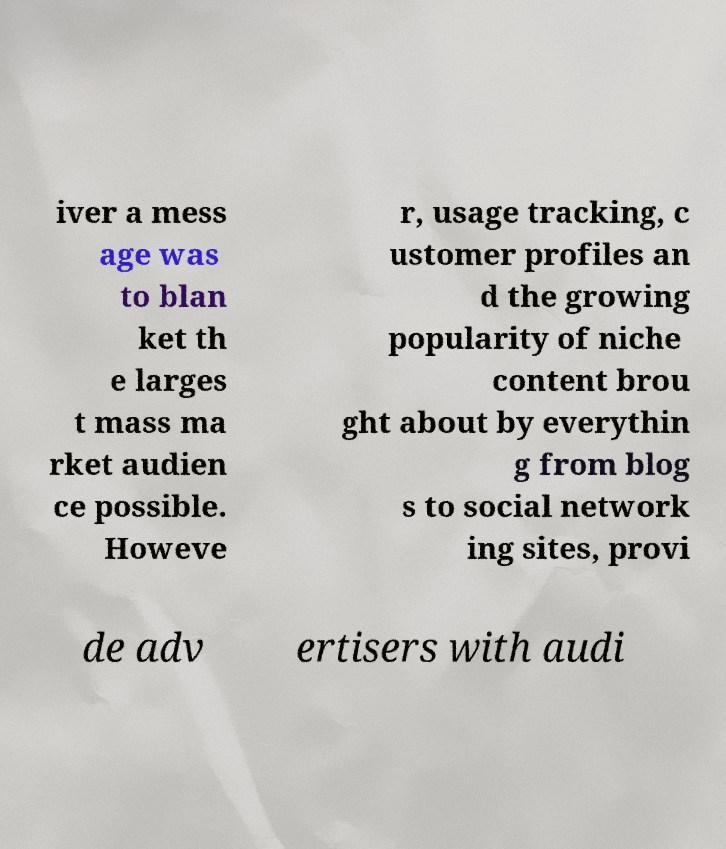Can you read and provide the text displayed in the image?This photo seems to have some interesting text. Can you extract and type it out for me? iver a mess age was to blan ket th e larges t mass ma rket audien ce possible. Howeve r, usage tracking, c ustomer profiles an d the growing popularity of niche content brou ght about by everythin g from blog s to social network ing sites, provi de adv ertisers with audi 